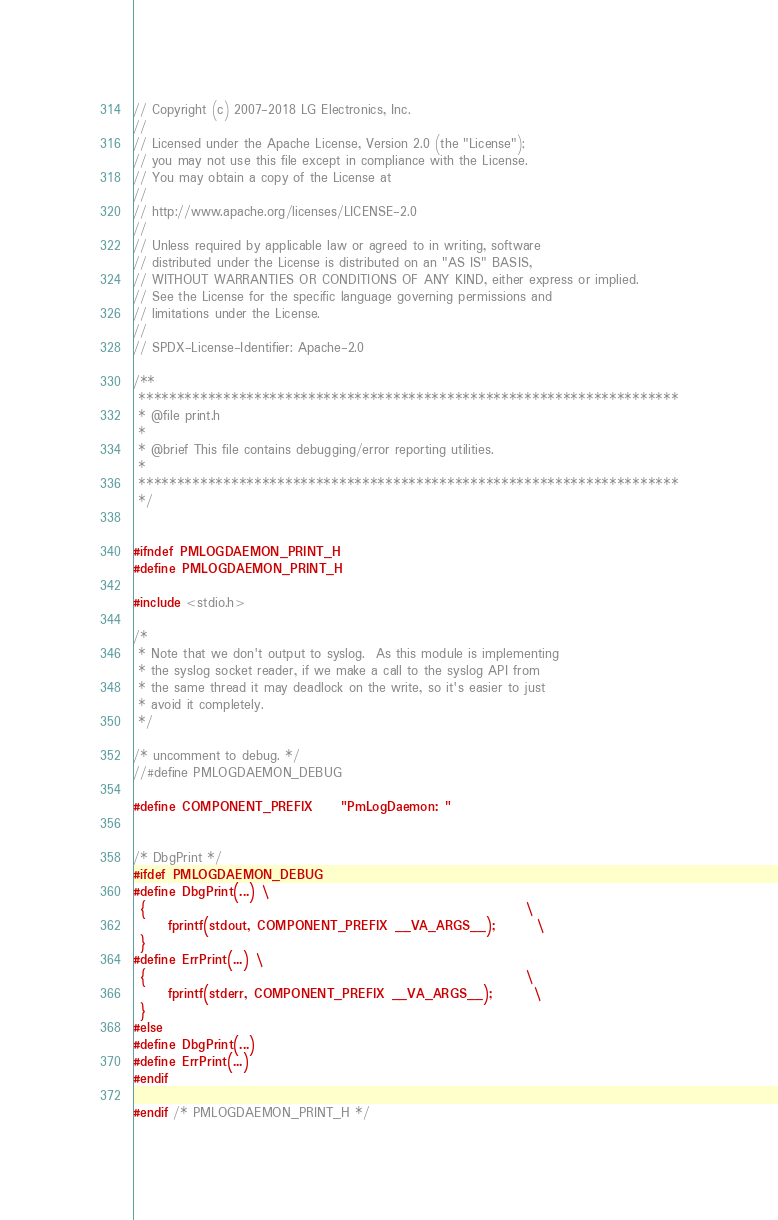Convert code to text. <code><loc_0><loc_0><loc_500><loc_500><_C_>// Copyright (c) 2007-2018 LG Electronics, Inc.
//
// Licensed under the Apache License, Version 2.0 (the "License");
// you may not use this file except in compliance with the License.
// You may obtain a copy of the License at
//
// http://www.apache.org/licenses/LICENSE-2.0
//
// Unless required by applicable law or agreed to in writing, software
// distributed under the License is distributed on an "AS IS" BASIS,
// WITHOUT WARRANTIES OR CONDITIONS OF ANY KIND, either express or implied.
// See the License for the specific language governing permissions and
// limitations under the License.
//
// SPDX-License-Identifier: Apache-2.0

/**
 **********************************************************************
 * @file print.h
 *
 * @brief This file contains debugging/error reporting utilities.
 *
 **********************************************************************
 */


#ifndef PMLOGDAEMON_PRINT_H
#define PMLOGDAEMON_PRINT_H

#include <stdio.h>

/*
 * Note that we don't output to syslog.  As this module is implementing
 * the syslog socket reader, if we make a call to the syslog API from
 * the same thread it may deadlock on the write, so it's easier to just
 * avoid it completely.
 */

/* uncomment to debug. */
//#define PMLOGDAEMON_DEBUG

#define COMPONENT_PREFIX    "PmLogDaemon: "


/* DbgPrint */
#ifdef PMLOGDAEMON_DEBUG
#define DbgPrint(...) \
 {                                                       \
     fprintf(stdout, COMPONENT_PREFIX __VA_ARGS__);      \
 }
#define ErrPrint(...) \
 {                                                       \
     fprintf(stderr, COMPONENT_PREFIX __VA_ARGS__);      \
 }
#else
#define DbgPrint(...)
#define ErrPrint(...)
#endif

#endif /* PMLOGDAEMON_PRINT_H */
</code> 